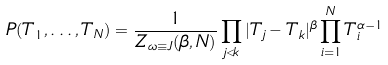<formula> <loc_0><loc_0><loc_500><loc_500>P ( T _ { 1 } , \dots , T _ { N } ) = \frac { 1 } { Z _ { \omega \equiv J } ( \beta , N ) } \prod _ { j < k } | T _ { j } - T _ { k } | ^ { \beta } \prod _ { i = 1 } ^ { N } T _ { i } ^ { \alpha - 1 }</formula> 